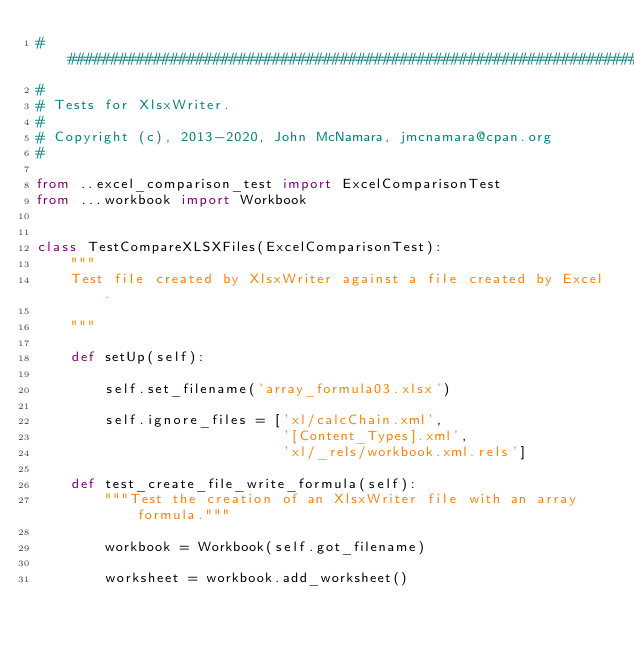<code> <loc_0><loc_0><loc_500><loc_500><_Python_>###############################################################################
#
# Tests for XlsxWriter.
#
# Copyright (c), 2013-2020, John McNamara, jmcnamara@cpan.org
#

from ..excel_comparison_test import ExcelComparisonTest
from ...workbook import Workbook


class TestCompareXLSXFiles(ExcelComparisonTest):
    """
    Test file created by XlsxWriter against a file created by Excel.

    """

    def setUp(self):

        self.set_filename('array_formula03.xlsx')

        self.ignore_files = ['xl/calcChain.xml',
                             '[Content_Types].xml',
                             'xl/_rels/workbook.xml.rels']

    def test_create_file_write_formula(self):
        """Test the creation of an XlsxWriter file with an array formula."""

        workbook = Workbook(self.got_filename)

        worksheet = workbook.add_worksheet()
</code> 